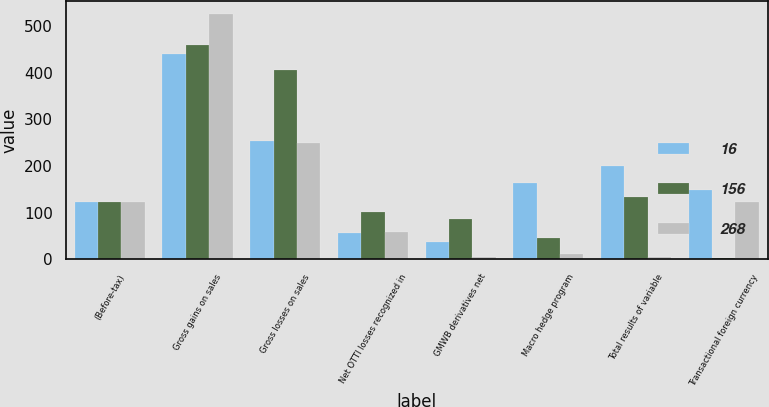Convert chart to OTSL. <chart><loc_0><loc_0><loc_500><loc_500><stacked_bar_chart><ecel><fcel>(Before-tax)<fcel>Gross gains on sales<fcel>Gross losses on sales<fcel>Net OTTI losses recognized in<fcel>GMWB derivatives net<fcel>Macro hedge program<fcel>Total results of variable<fcel>Transactional foreign currency<nl><fcel>16<fcel>124<fcel>441<fcel>253<fcel>56<fcel>38<fcel>163<fcel>201<fcel>148<nl><fcel>156<fcel>124<fcel>460<fcel>405<fcel>102<fcel>87<fcel>46<fcel>133<fcel>4<nl><fcel>268<fcel>124<fcel>527<fcel>250<fcel>59<fcel>5<fcel>11<fcel>6<fcel>124<nl></chart> 